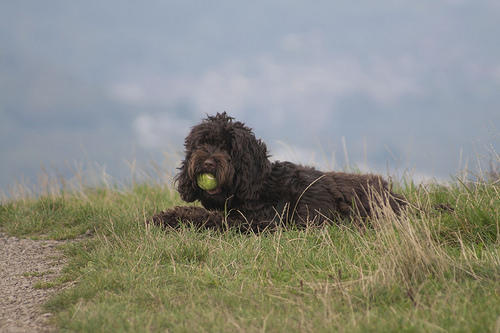<image>
Is the ball in the dog? Yes. The ball is contained within or inside the dog, showing a containment relationship. 